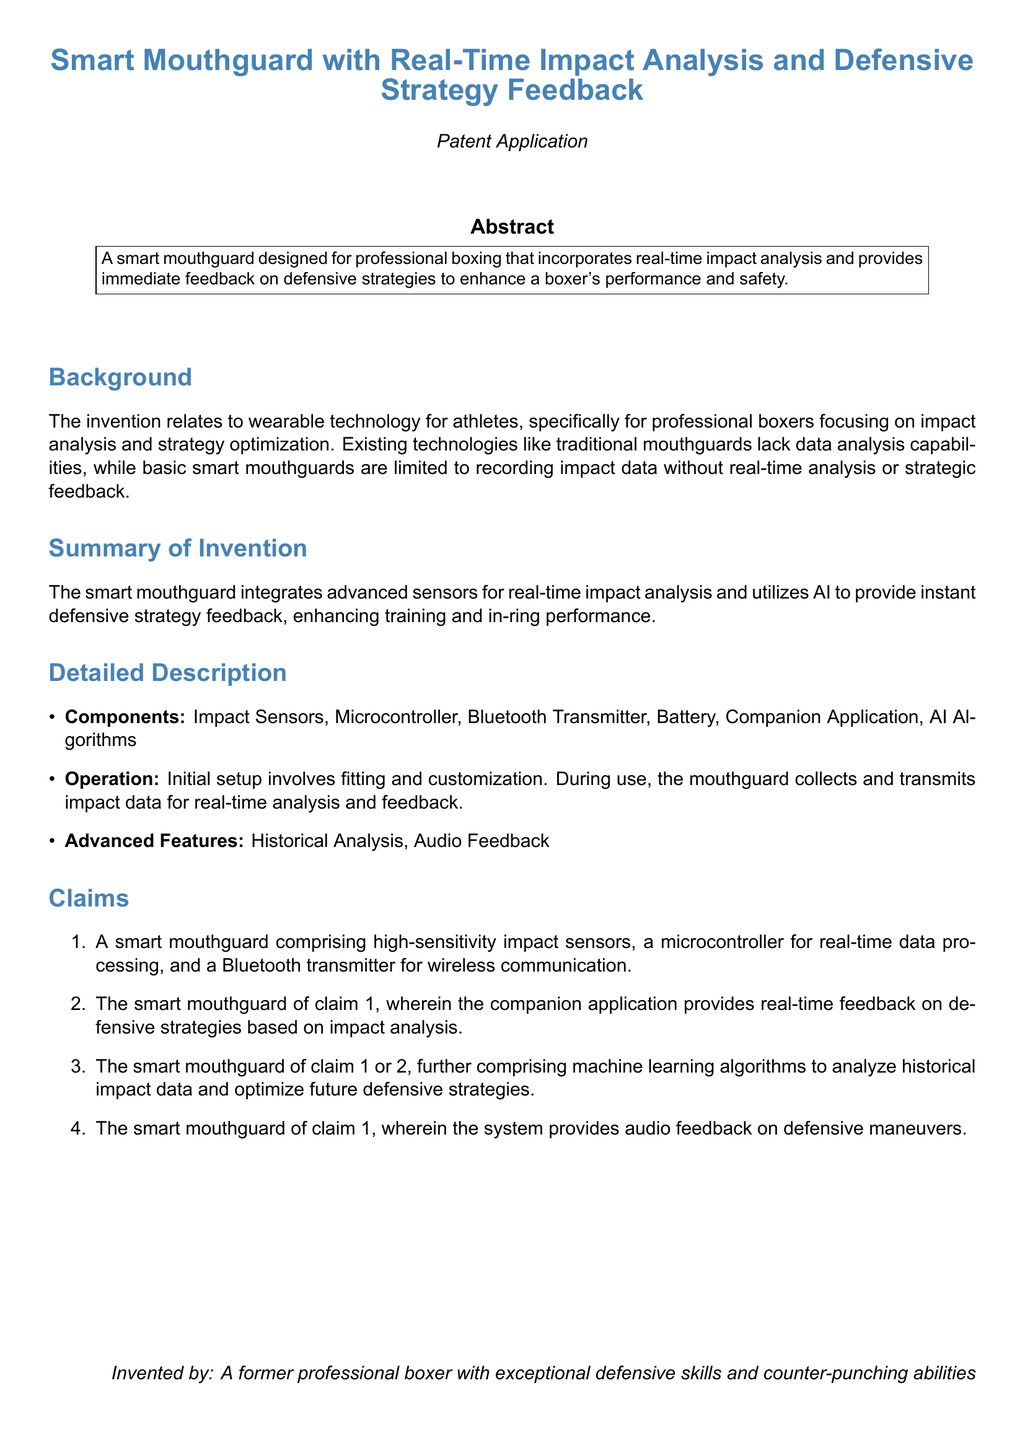What is the title of the patent application? The title of the patent application is listed at the top of the document.
Answer: Smart Mouthguard with Real-Time Impact Analysis and Defensive Strategy Feedback What does the smart mouthguard provide feedback on? The document states that the mouthguard provides feedback on defensive strategies.
Answer: Defensive strategies How many claims does the patent application include? The claims section of the document contains several enumerated claims.
Answer: Four What technology does the smart mouthguard use to process data? The detailed description mentions a specific component that processes data.
Answer: Microcontroller What is one of the advanced features of the smart mouthguard? The document lists additional functionalities of the mouthguard in the detailed description.
Answer: Audio Feedback What type of technology is the invention focused on? The background section indicates the general focus of the invention.
Answer: Wearable technology Who invented the smart mouthguard? The inventors' information is provided in the document towards the end.
Answer: A former professional boxer What component is used for wireless communication in the mouthguard? The claims section indicates a specific component for communication.
Answer: Bluetooth Transmitter 